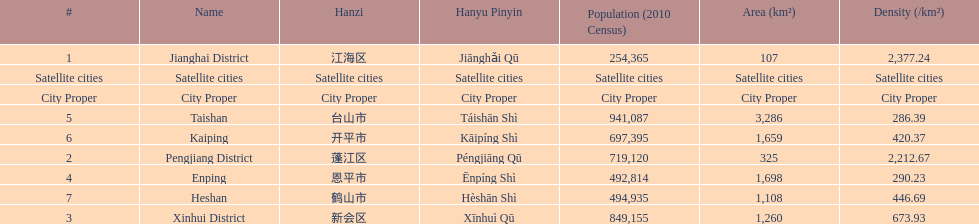What city proper has the smallest area in km2? Jianghai District. 